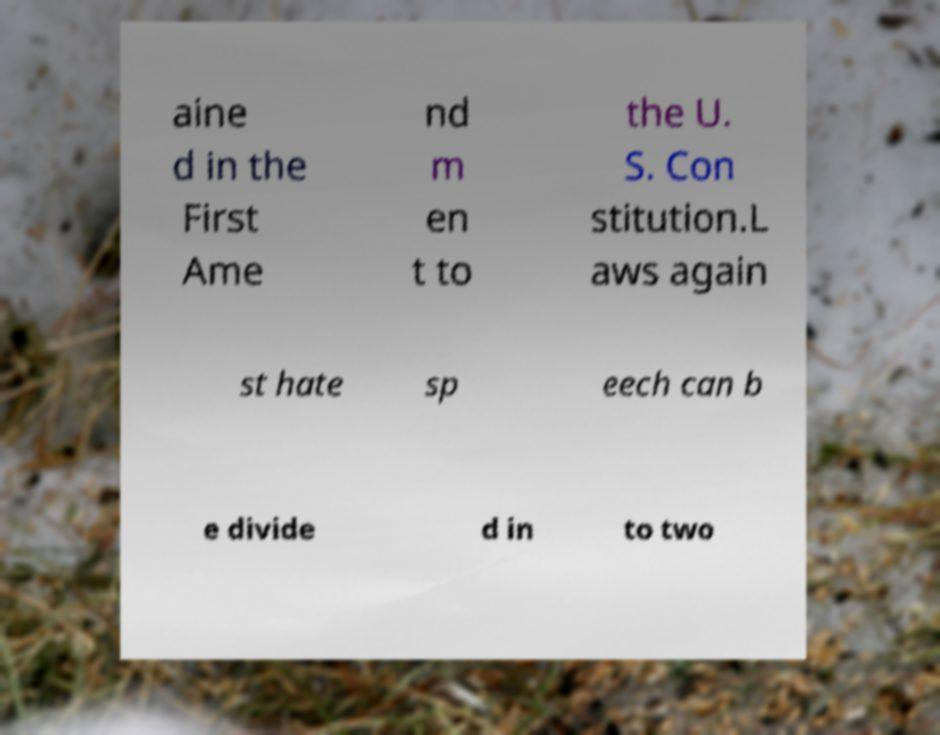Please identify and transcribe the text found in this image. aine d in the First Ame nd m en t to the U. S. Con stitution.L aws again st hate sp eech can b e divide d in to two 